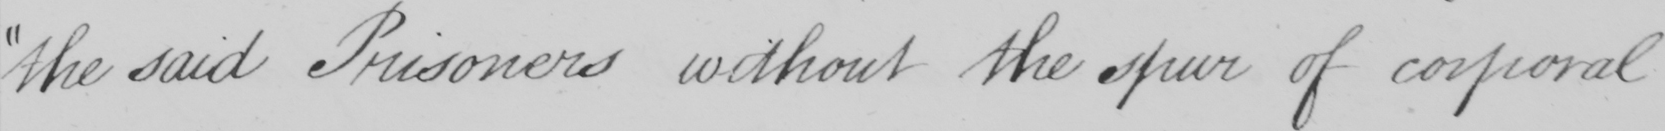Can you read and transcribe this handwriting? the said Prisoners without the spur of corporal 